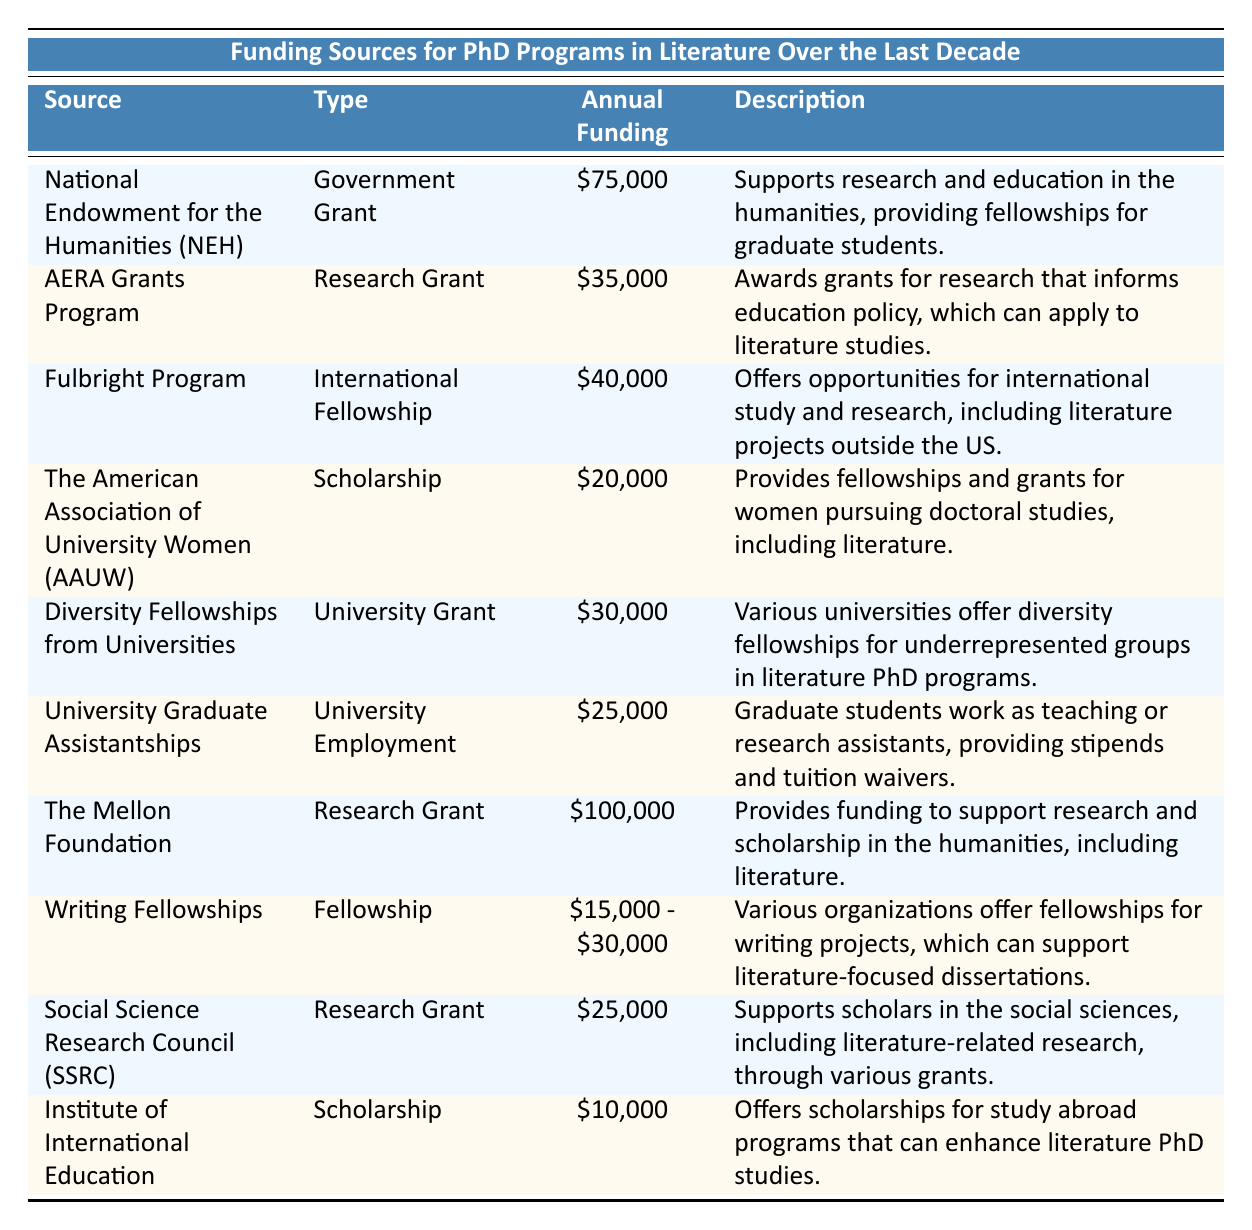What is the annual funding provided by the National Endowment for the Humanities? The table explicitly lists the annual funding amount for the National Endowment for the Humanities (NEH) as $75,000.
Answer: $75,000 Which funding source offers the lowest annual funding? The table indicates that the Institute of International Education offers the lowest annual funding of $10,000.
Answer: $10,000 What type of funding does The Mellon Foundation represent? The table categorizes The Mellon Foundation as a Research Grant.
Answer: Research Grant What is the total annual funding of the AERA Grants Program and University Graduate Assistantships? Summing the annual funding amounts gives us $35,000 (AERA Grants Program) + $25,000 (University Graduate Assistantships) = $60,000.
Answer: $60,000 Are there any fellowships specifically for women pursuing doctoral studies? The table mentions that the American Association of University Women (AAUW) provides fellowships for women pursuing doctoral studies.
Answer: Yes Which source provides the widest range of annual funding? The Writing Fellowships have a range of $15,000 to $30,000, which is the widest range indicated in the table.
Answer: Writing Fellowships What is the average annual funding of the Research Grants listed? To calculate the average: The Mellon Foundation ($100,000) + AERA Grants Program ($35,000) + Social Science Research Council ($25,000) = $160,000. There are 3 research grants, so the average is $160,000/3 = $53,333.33.
Answer: $53,333.33 Is it true that all sources listed support research in the humanities? While most sources support research in humanities, the AERA Grants Program focuses on informing education policy which can apply to literature studies but isn't strictly humanities. Therefore, the answer is false.
Answer: No What type of funding does the Fulbright Program provide? The table classifies the Fulbright Program as an International Fellowship.
Answer: International Fellowship What is the difference in annual funding between The Mellon Foundation and The American Association of University Women (AAUW)? Subtracting the AAUW funding ($20,000) from The Mellon Foundation funding ($100,000) gives us $100,000 - $20,000 = $80,000.
Answer: $80,000 